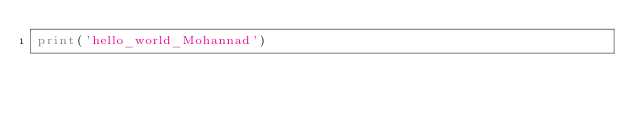<code> <loc_0><loc_0><loc_500><loc_500><_Python_>print('hello_world_Mohannad')
</code> 